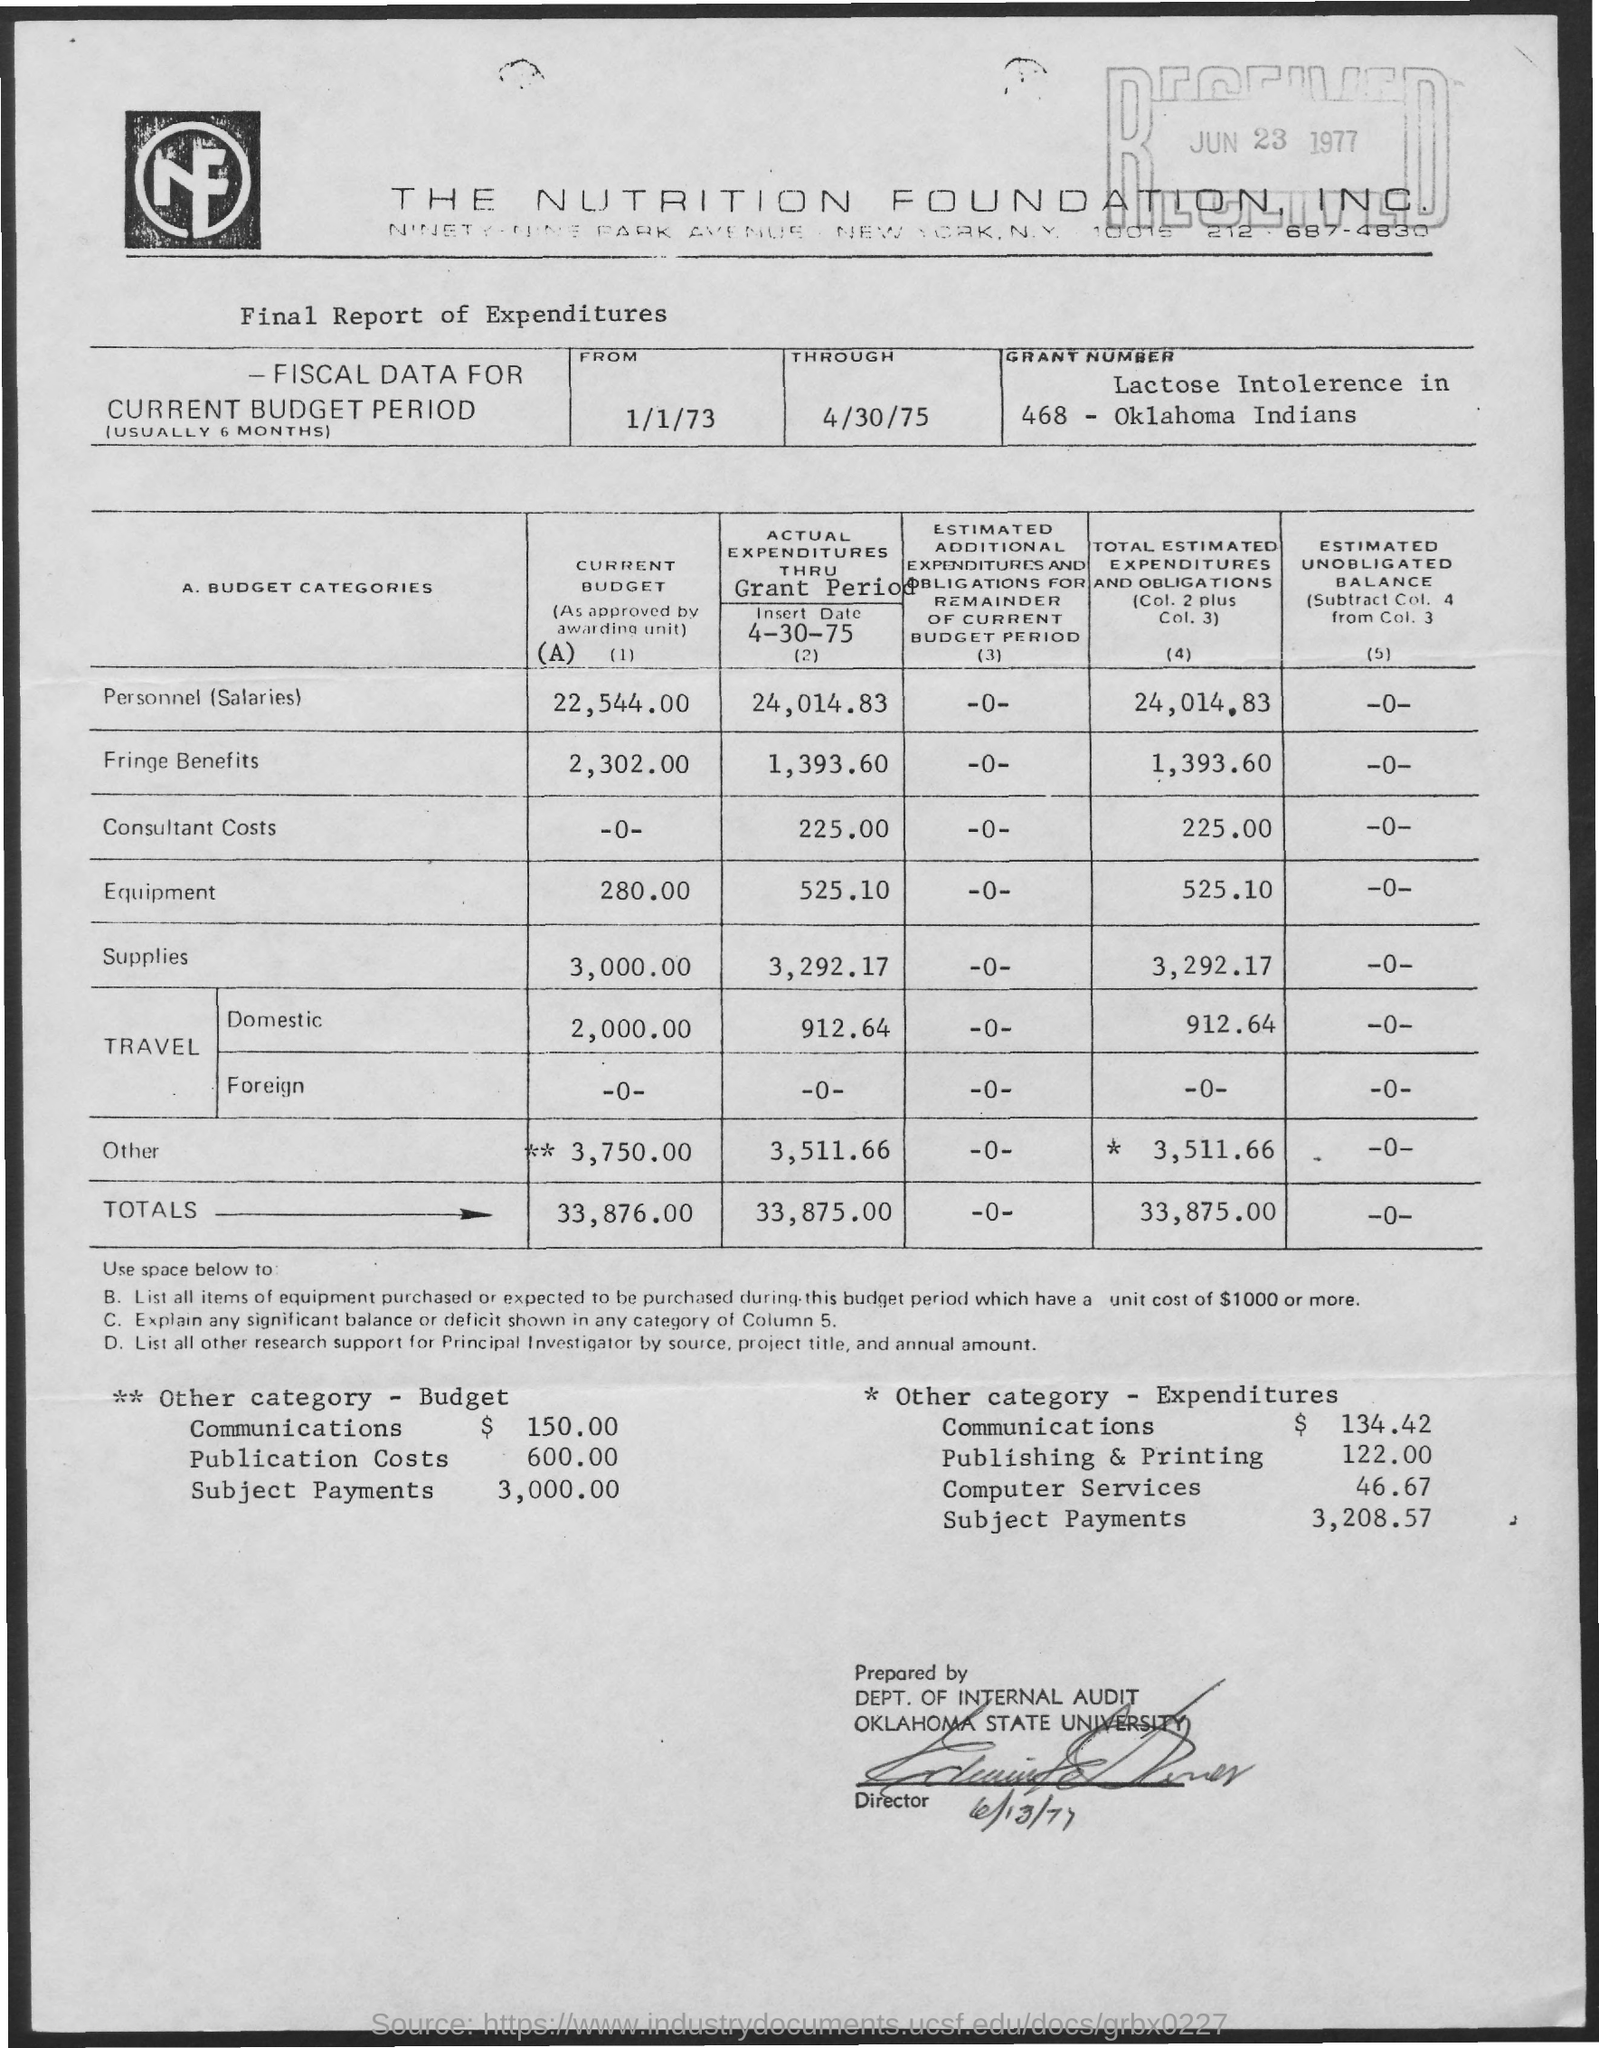What is the name of company?
Make the answer very short. The Nutrition Foundation. INC. What is the total of current budget?
Make the answer very short. 33,876.00. 